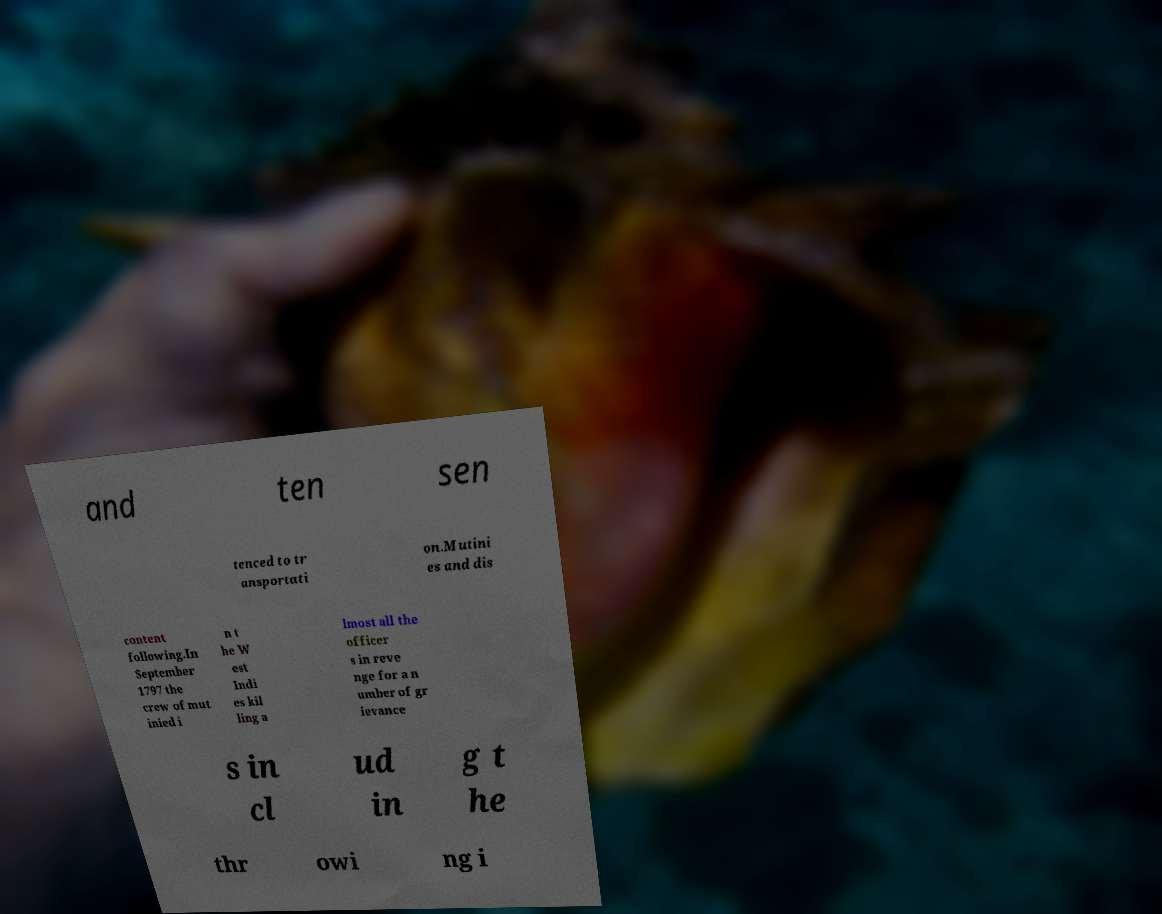Could you assist in decoding the text presented in this image and type it out clearly? and ten sen tenced to tr ansportati on.Mutini es and dis content following.In September 1797 the crew of mut inied i n t he W est Indi es kil ling a lmost all the officer s in reve nge for a n umber of gr ievance s in cl ud in g t he thr owi ng i 